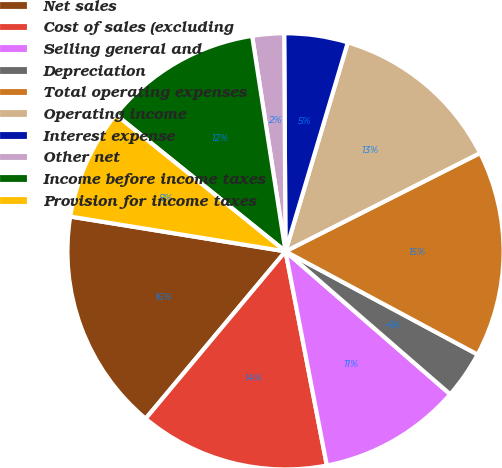Convert chart to OTSL. <chart><loc_0><loc_0><loc_500><loc_500><pie_chart><fcel>Net sales<fcel>Cost of sales (excluding<fcel>Selling general and<fcel>Depreciation<fcel>Total operating expenses<fcel>Operating income<fcel>Interest expense<fcel>Other net<fcel>Income before income taxes<fcel>Provision for income taxes<nl><fcel>16.47%<fcel>14.12%<fcel>10.59%<fcel>3.53%<fcel>15.29%<fcel>12.94%<fcel>4.71%<fcel>2.35%<fcel>11.76%<fcel>8.24%<nl></chart> 